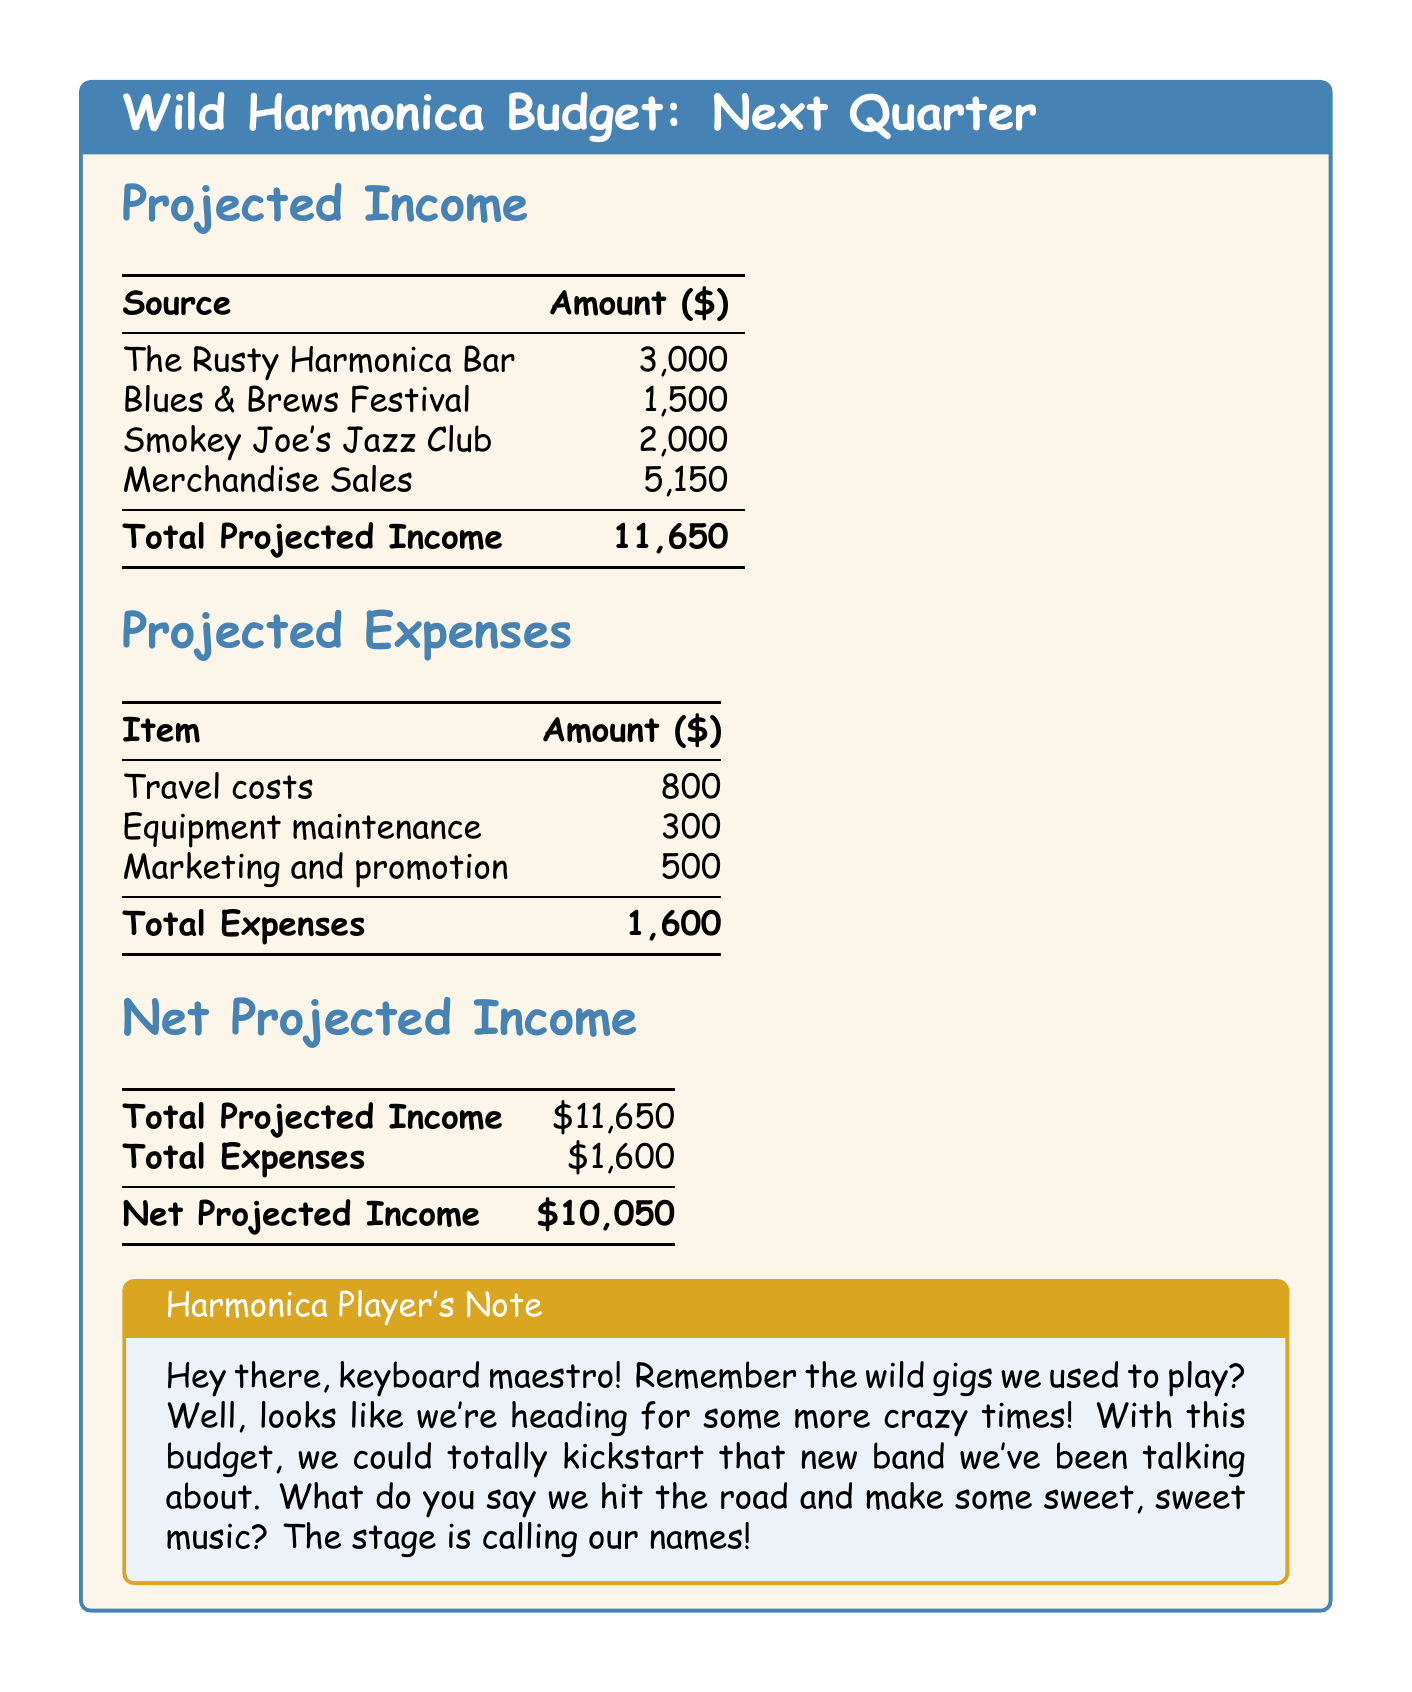What is the total projected income? The total projected income is calculated by summing all individual income sources listed in the document, which totals to $11,650.
Answer: $11,650 How much is projected from merchandise sales? The merchandise sales income is explicitly stated in the document as $5,150.
Answer: $5,150 What is the total of travel costs? The travel costs are specified in the expenses section and amount to $800.
Answer: $800 What are the total expenses? The total expenses are the sum of all listed expenses, which is calculated to be $1,600 in the document.
Answer: $1,600 What is the net projected income? The net projected income is calculated by subtracting total expenses from total projected income, resulting in $10,050.
Answer: $10,050 Which gig offers the highest income? The highest income from gigs is from The Rusty Harmonica Bar, which is $3,000.
Answer: The Rusty Harmonica Bar How much is allocated for marketing and promotion? The marketing and promotion costs are directly provided in the expenses section as $500.
Answer: $500 What color is used for the budget title background? The budget title background color is described as jazzgold, which is mixed with 10% transparency.
Answer: jazzgold What is the expected income from Blues & Brews Festival? The expected income from the Blues & Brews Festival is stated as $1,500 in the document.
Answer: $1,500 